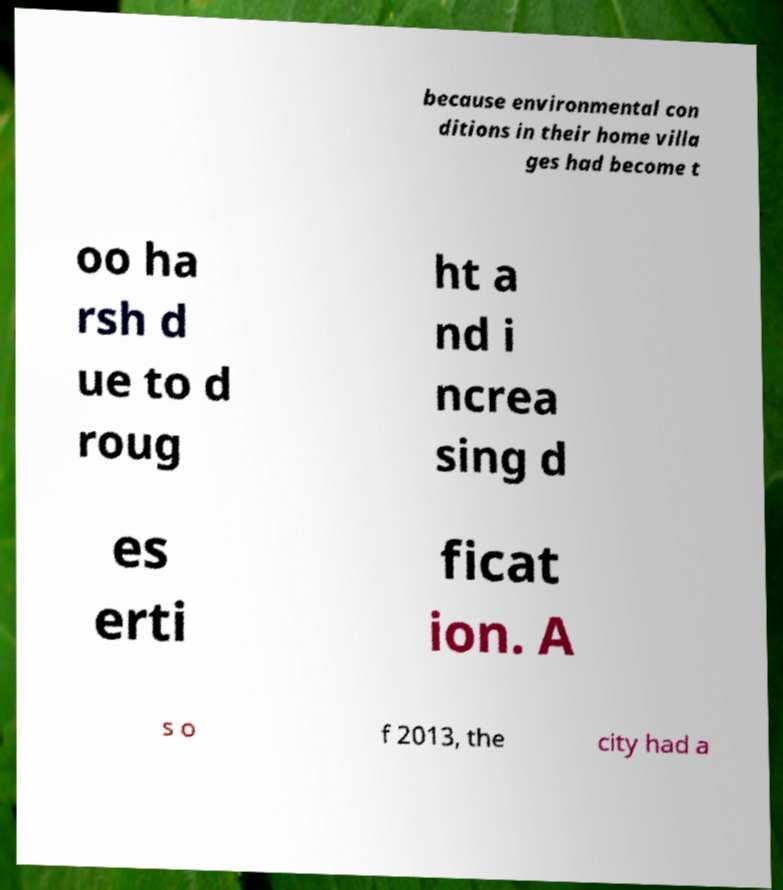Please read and relay the text visible in this image. What does it say? because environmental con ditions in their home villa ges had become t oo ha rsh d ue to d roug ht a nd i ncrea sing d es erti ficat ion. A s o f 2013, the city had a 